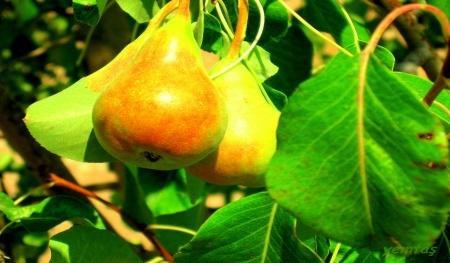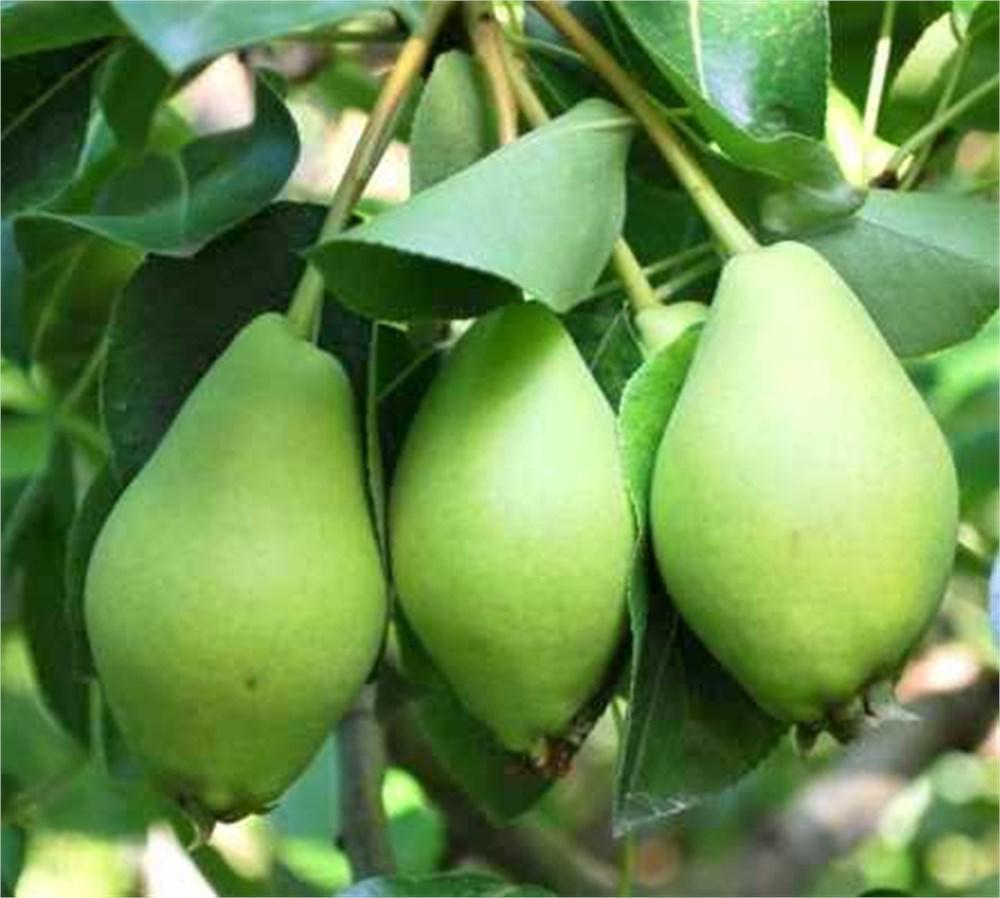The first image is the image on the left, the second image is the image on the right. For the images displayed, is the sentence "At least one of the images shows fruit hanging on a tree." factually correct? Answer yes or no. Yes. 